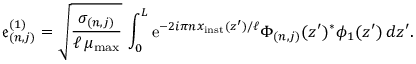<formula> <loc_0><loc_0><loc_500><loc_500>\mathfrak { e } _ { ( n , j ) } ^ { ( 1 ) } = \sqrt { \frac { \sigma _ { ( n , j ) } } { \ell \, \mu _ { \max } } } \, \int _ { 0 } ^ { L } e ^ { - 2 i \pi n x _ { i n s t } ( z ^ { \prime } ) / \ell } \Phi _ { ( n , j ) } ( z ^ { \prime } ) ^ { \ast } \phi _ { 1 } ( z ^ { \prime } ) \, d z ^ { \prime } .</formula> 